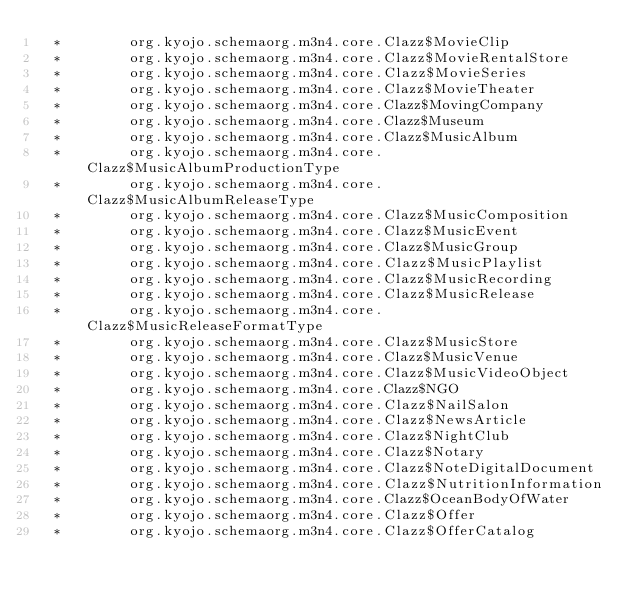<code> <loc_0><loc_0><loc_500><loc_500><_SQL_>  *        org.kyojo.schemaorg.m3n4.core.Clazz$MovieClip
  *        org.kyojo.schemaorg.m3n4.core.Clazz$MovieRentalStore
  *        org.kyojo.schemaorg.m3n4.core.Clazz$MovieSeries
  *        org.kyojo.schemaorg.m3n4.core.Clazz$MovieTheater
  *        org.kyojo.schemaorg.m3n4.core.Clazz$MovingCompany
  *        org.kyojo.schemaorg.m3n4.core.Clazz$Museum
  *        org.kyojo.schemaorg.m3n4.core.Clazz$MusicAlbum
  *        org.kyojo.schemaorg.m3n4.core.Clazz$MusicAlbumProductionType
  *        org.kyojo.schemaorg.m3n4.core.Clazz$MusicAlbumReleaseType
  *        org.kyojo.schemaorg.m3n4.core.Clazz$MusicComposition
  *        org.kyojo.schemaorg.m3n4.core.Clazz$MusicEvent
  *        org.kyojo.schemaorg.m3n4.core.Clazz$MusicGroup
  *        org.kyojo.schemaorg.m3n4.core.Clazz$MusicPlaylist
  *        org.kyojo.schemaorg.m3n4.core.Clazz$MusicRecording
  *        org.kyojo.schemaorg.m3n4.core.Clazz$MusicRelease
  *        org.kyojo.schemaorg.m3n4.core.Clazz$MusicReleaseFormatType
  *        org.kyojo.schemaorg.m3n4.core.Clazz$MusicStore
  *        org.kyojo.schemaorg.m3n4.core.Clazz$MusicVenue
  *        org.kyojo.schemaorg.m3n4.core.Clazz$MusicVideoObject
  *        org.kyojo.schemaorg.m3n4.core.Clazz$NGO
  *        org.kyojo.schemaorg.m3n4.core.Clazz$NailSalon
  *        org.kyojo.schemaorg.m3n4.core.Clazz$NewsArticle
  *        org.kyojo.schemaorg.m3n4.core.Clazz$NightClub
  *        org.kyojo.schemaorg.m3n4.core.Clazz$Notary
  *        org.kyojo.schemaorg.m3n4.core.Clazz$NoteDigitalDocument
  *        org.kyojo.schemaorg.m3n4.core.Clazz$NutritionInformation
  *        org.kyojo.schemaorg.m3n4.core.Clazz$OceanBodyOfWater
  *        org.kyojo.schemaorg.m3n4.core.Clazz$Offer
  *        org.kyojo.schemaorg.m3n4.core.Clazz$OfferCatalog</code> 